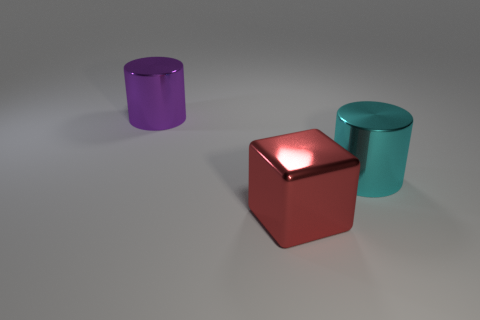Add 1 large cyan cylinders. How many objects exist? 4 Subtract all blocks. How many objects are left? 2 Add 3 big purple objects. How many big purple objects exist? 4 Subtract 1 red blocks. How many objects are left? 2 Subtract all gray cylinders. Subtract all gray blocks. How many cylinders are left? 2 Subtract all tiny yellow rubber spheres. Subtract all big cylinders. How many objects are left? 1 Add 3 purple cylinders. How many purple cylinders are left? 4 